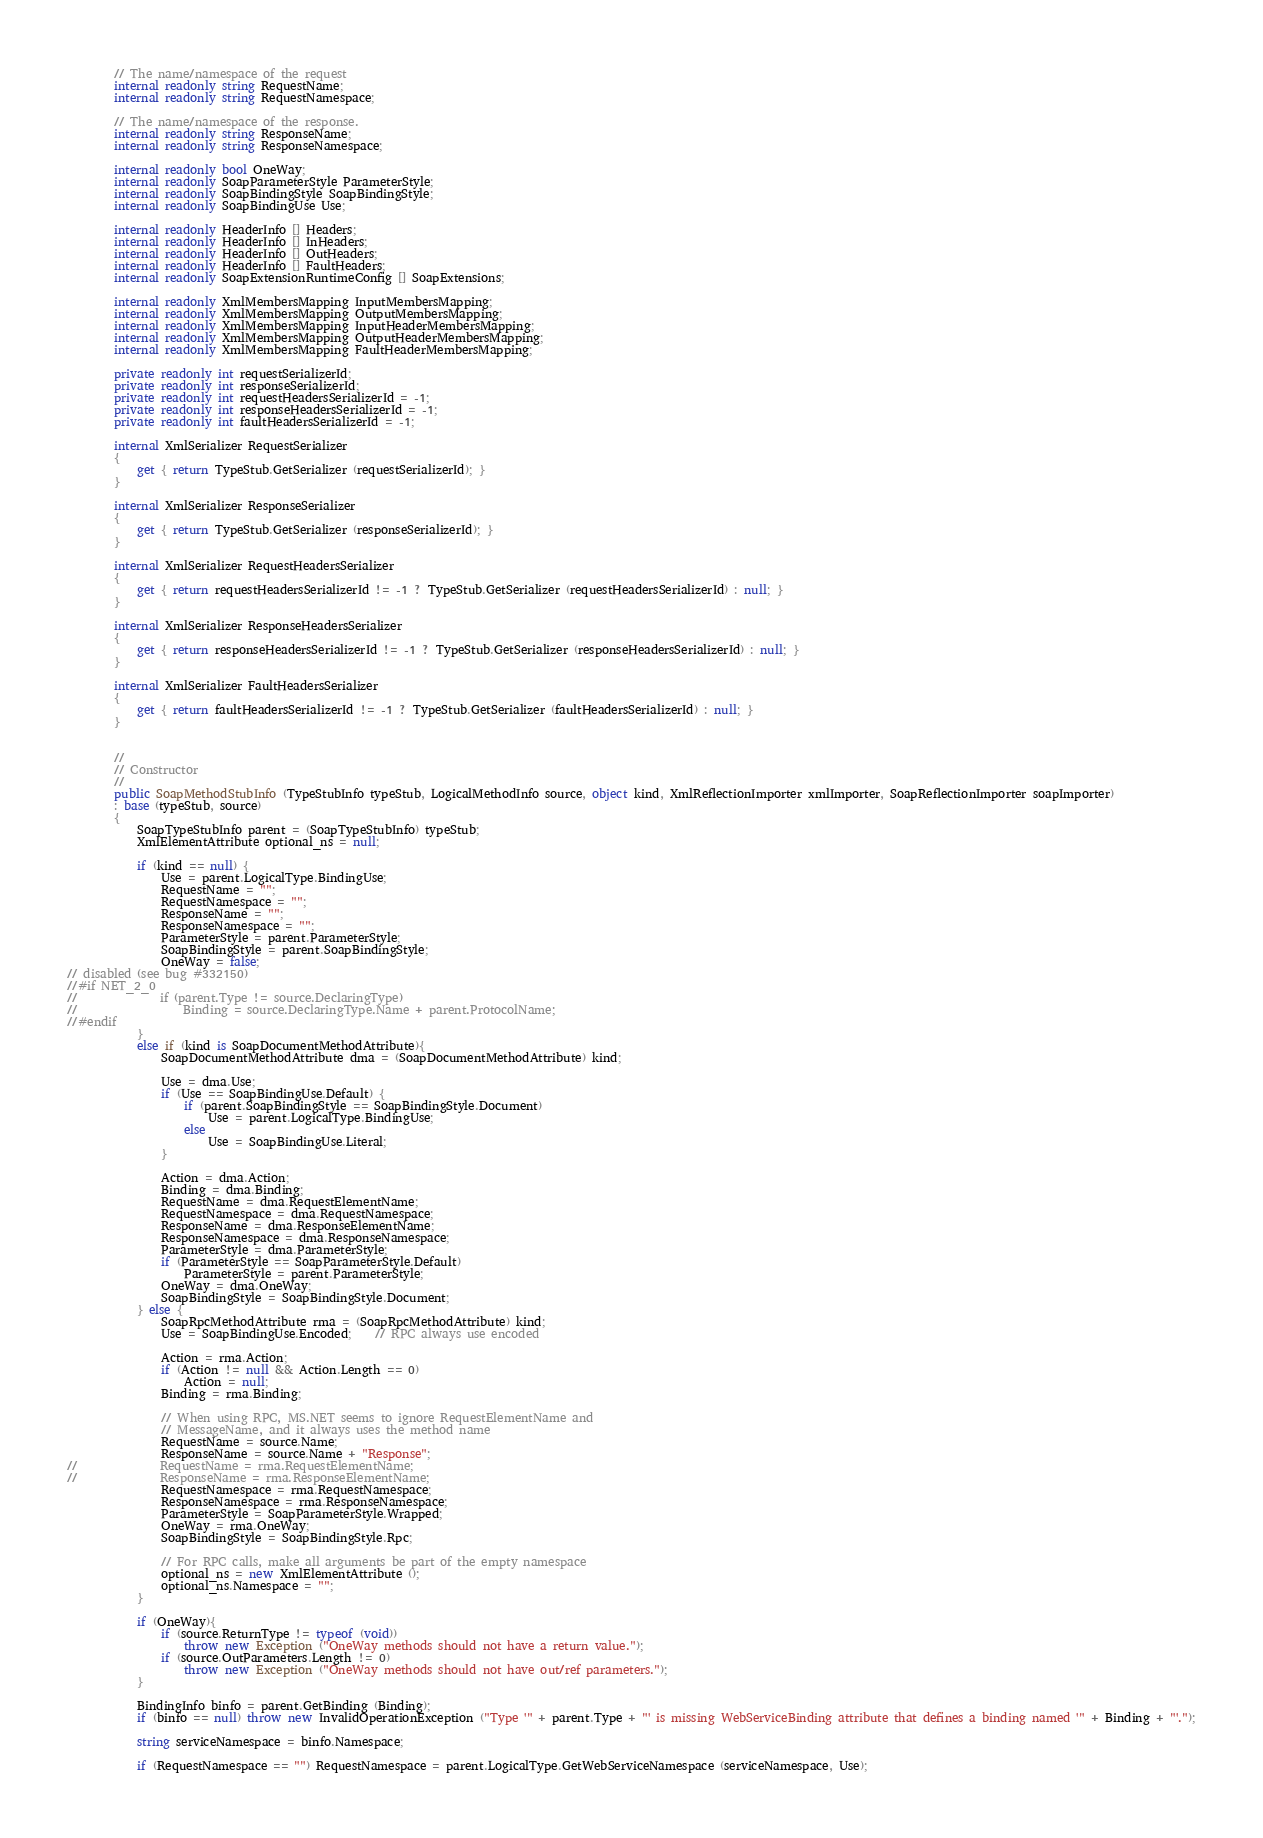Convert code to text. <code><loc_0><loc_0><loc_500><loc_500><_C#_>
		// The name/namespace of the request 
		internal readonly string RequestName;
		internal readonly string RequestNamespace;

		// The name/namespace of the response.
		internal readonly string ResponseName;
		internal readonly string ResponseNamespace;

		internal readonly bool OneWay;
		internal readonly SoapParameterStyle ParameterStyle;
		internal readonly SoapBindingStyle SoapBindingStyle;
		internal readonly SoapBindingUse Use;

		internal readonly HeaderInfo [] Headers;
		internal readonly HeaderInfo [] InHeaders;
		internal readonly HeaderInfo [] OutHeaders;
		internal readonly HeaderInfo [] FaultHeaders;
		internal readonly SoapExtensionRuntimeConfig [] SoapExtensions;

		internal readonly XmlMembersMapping InputMembersMapping;
		internal readonly XmlMembersMapping OutputMembersMapping;
		internal readonly XmlMembersMapping InputHeaderMembersMapping;
		internal readonly XmlMembersMapping OutputHeaderMembersMapping;
		internal readonly XmlMembersMapping FaultHeaderMembersMapping;

		private readonly int requestSerializerId;
		private readonly int responseSerializerId;
		private readonly int requestHeadersSerializerId = -1;
		private readonly int responseHeadersSerializerId = -1;
		private readonly int faultHeadersSerializerId = -1;
		
		internal XmlSerializer RequestSerializer
		{
			get { return TypeStub.GetSerializer (requestSerializerId); }
		}
		
		internal XmlSerializer ResponseSerializer
		{
			get { return TypeStub.GetSerializer (responseSerializerId); }
		}
		
		internal XmlSerializer RequestHeadersSerializer
		{
			get { return requestHeadersSerializerId != -1 ? TypeStub.GetSerializer (requestHeadersSerializerId) : null; }
		}
		
		internal XmlSerializer ResponseHeadersSerializer
		{
			get { return responseHeadersSerializerId != -1 ? TypeStub.GetSerializer (responseHeadersSerializerId) : null; }
		}
		
		internal XmlSerializer FaultHeadersSerializer
		{
			get { return faultHeadersSerializerId != -1 ? TypeStub.GetSerializer (faultHeadersSerializerId) : null; }
		}
		

		//
		// Constructor
		//
		public SoapMethodStubInfo (TypeStubInfo typeStub, LogicalMethodInfo source, object kind, XmlReflectionImporter xmlImporter, SoapReflectionImporter soapImporter)
		: base (typeStub, source)
		{
			SoapTypeStubInfo parent = (SoapTypeStubInfo) typeStub;
			XmlElementAttribute optional_ns = null;

			if (kind == null) {
				Use = parent.LogicalType.BindingUse;
				RequestName = "";
				RequestNamespace = "";
				ResponseName = "";
				ResponseNamespace = "";
				ParameterStyle = parent.ParameterStyle;
				SoapBindingStyle = parent.SoapBindingStyle;
				OneWay = false;
// disabled (see bug #332150)
//#if NET_2_0
//				if (parent.Type != source.DeclaringType)
//					Binding = source.DeclaringType.Name + parent.ProtocolName;
//#endif
			}
			else if (kind is SoapDocumentMethodAttribute){
				SoapDocumentMethodAttribute dma = (SoapDocumentMethodAttribute) kind;
				
				Use = dma.Use;
				if (Use == SoapBindingUse.Default) {
					if (parent.SoapBindingStyle == SoapBindingStyle.Document)
						Use = parent.LogicalType.BindingUse;
					else
						Use = SoapBindingUse.Literal;
				}
				
				Action = dma.Action;
				Binding = dma.Binding;
				RequestName = dma.RequestElementName;
				RequestNamespace = dma.RequestNamespace;
				ResponseName = dma.ResponseElementName;
				ResponseNamespace = dma.ResponseNamespace;
				ParameterStyle = dma.ParameterStyle;
				if (ParameterStyle == SoapParameterStyle.Default)
					ParameterStyle = parent.ParameterStyle;
				OneWay = dma.OneWay;
				SoapBindingStyle = SoapBindingStyle.Document;
			} else {
				SoapRpcMethodAttribute rma = (SoapRpcMethodAttribute) kind;
				Use = SoapBindingUse.Encoded;	// RPC always use encoded

				Action = rma.Action;
				if (Action != null && Action.Length == 0)
					Action = null;
				Binding = rma.Binding;
				
				// When using RPC, MS.NET seems to ignore RequestElementName and
				// MessageName, and it always uses the method name
				RequestName = source.Name;
				ResponseName = source.Name + "Response";
//				RequestName = rma.RequestElementName;
//				ResponseName = rma.ResponseElementName;
				RequestNamespace = rma.RequestNamespace;
				ResponseNamespace = rma.ResponseNamespace;
				ParameterStyle = SoapParameterStyle.Wrapped;
				OneWay = rma.OneWay;
				SoapBindingStyle = SoapBindingStyle.Rpc;

				// For RPC calls, make all arguments be part of the empty namespace
				optional_ns = new XmlElementAttribute ();
				optional_ns.Namespace = "";
			}

			if (OneWay){
				if (source.ReturnType != typeof (void))
					throw new Exception ("OneWay methods should not have a return value.");
				if (source.OutParameters.Length != 0)
					throw new Exception ("OneWay methods should not have out/ref parameters.");
			}
			
			BindingInfo binfo = parent.GetBinding (Binding);
			if (binfo == null) throw new InvalidOperationException ("Type '" + parent.Type + "' is missing WebServiceBinding attribute that defines a binding named '" + Binding + "'.");
			
			string serviceNamespace = binfo.Namespace;
				
			if (RequestNamespace == "") RequestNamespace = parent.LogicalType.GetWebServiceNamespace (serviceNamespace, Use);</code> 